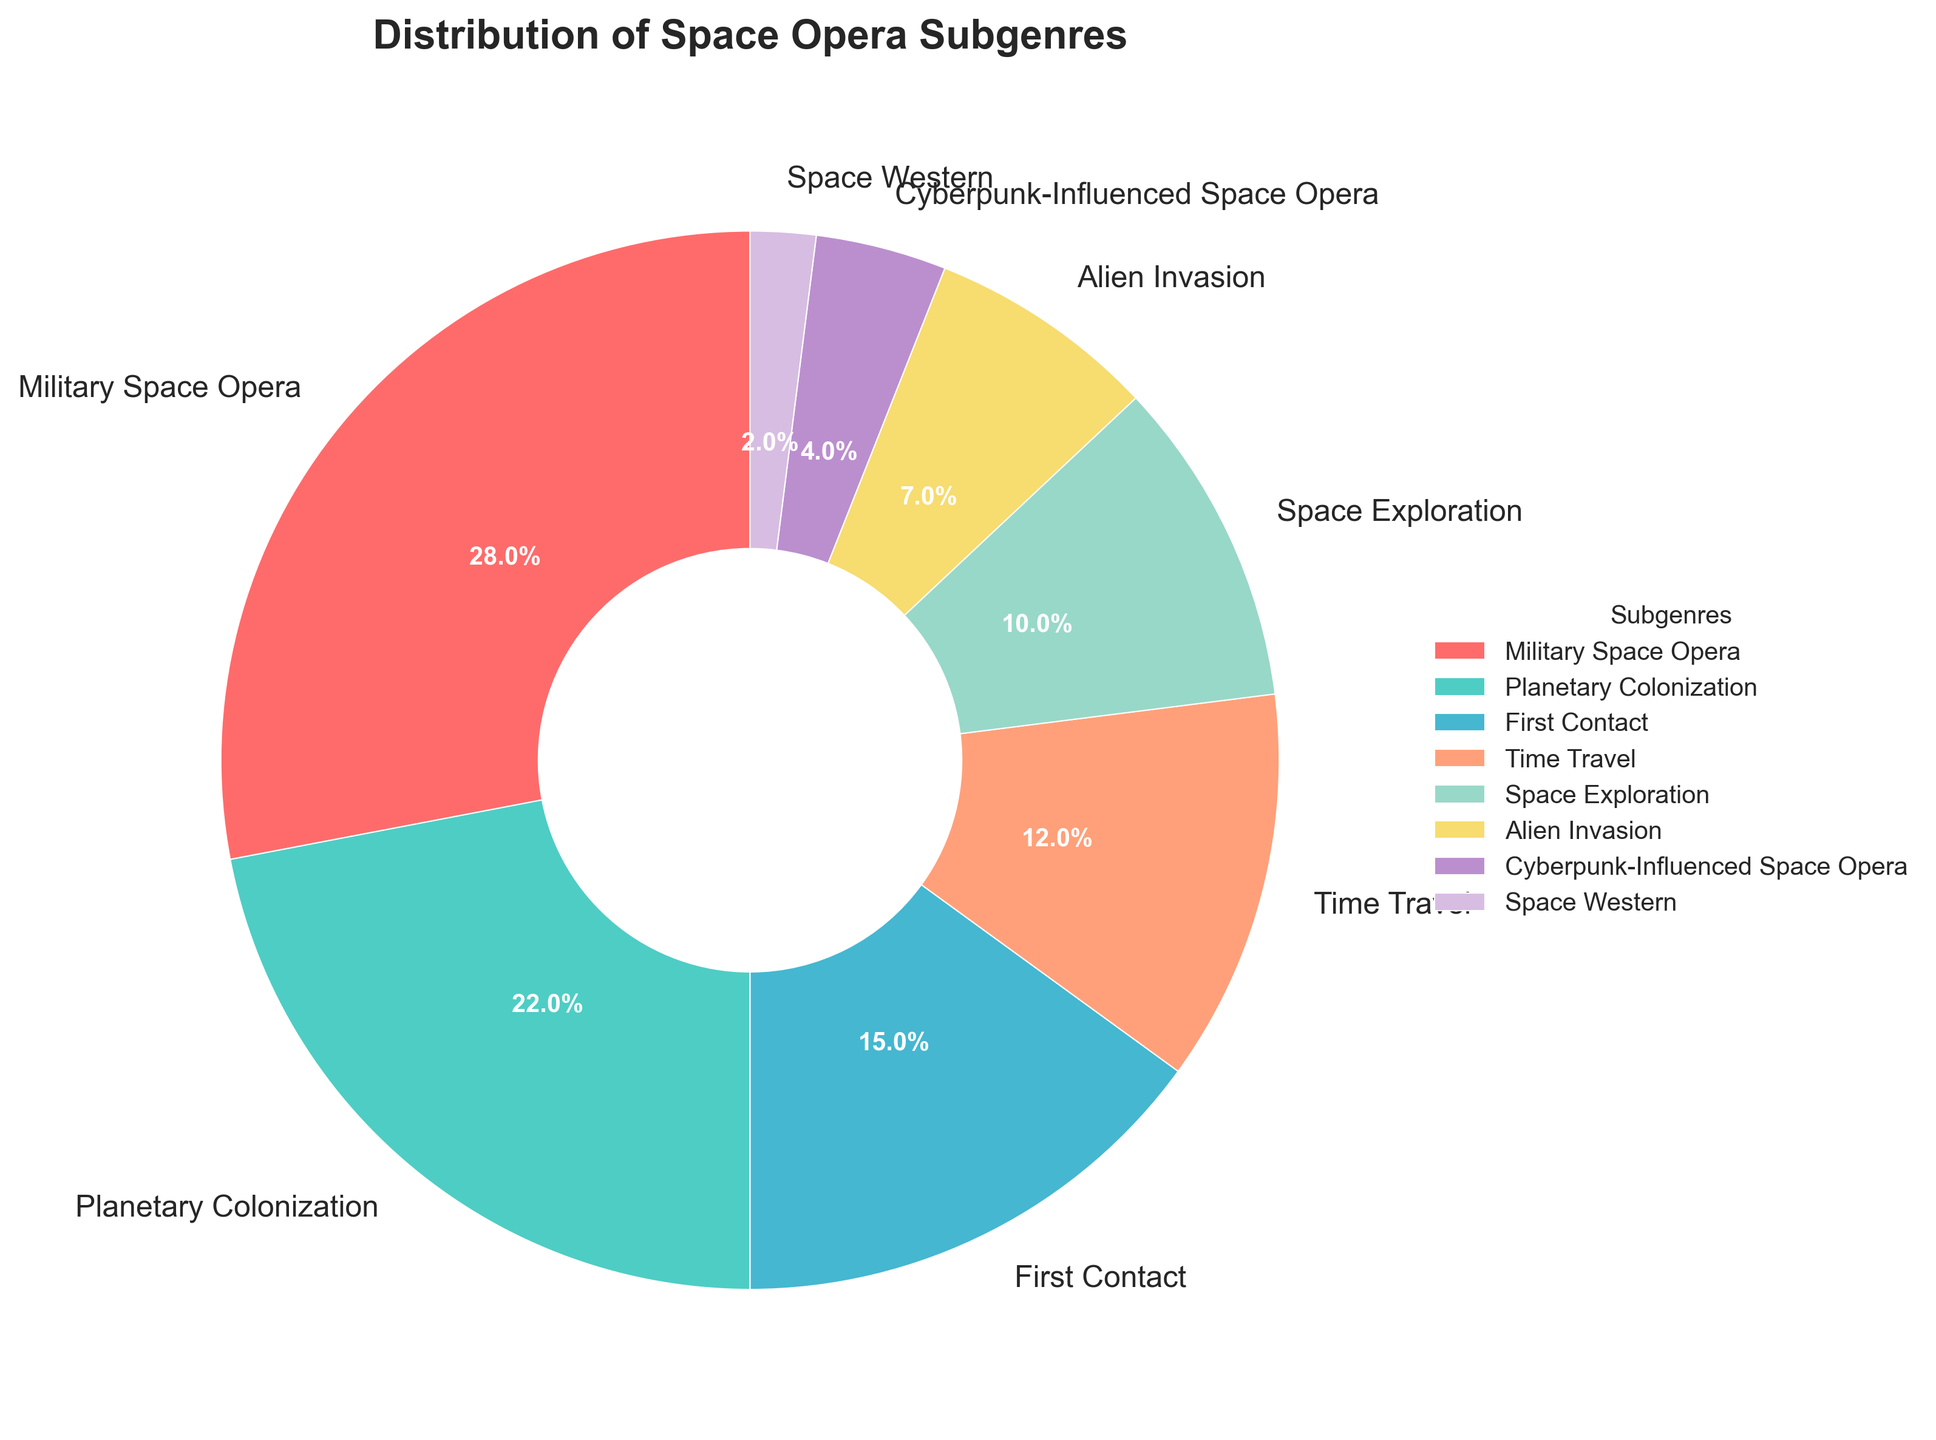What's the most popular space opera subgenre in the bookstore's sales? The chart shows that "Military Space Opera" has the highest percentage among all subgenres. By observing the labels and comparing the percentages visually, it is clear that this subgenre leads with 28%.
Answer: Military Space Opera How many subgenres have sales percentages greater than 10%? By examining the pie chart's labels, there are four subgenres with percentages higher than 10%. These are "Military Space Opera" (28%), "Planetary Colonization" (22%), "First Contact" (15%), and "Time Travel" (12%).
Answer: 4 Are there more sales in "Time Travel" or "Space Exploration"? Looking at the pie chart, "Time Travel" shows a percentage of 12%, while "Space Exploration" has a percentage of 10%. Comparing these values, it is clear that "Time Travel" subgenre has more sales.
Answer: Time Travel What's the combined percentage of the two least popular subgenres? The two least popular subgenres according to the chart are "Cyberpunk-Influenced Space Opera" (4%) and "Space Western" (2%). Adding these percentages together results in 4% + 2% = 6%.
Answer: 6% Which subgenre is represented by the yellow segment in the pie chart? By observing the color scheme in the pie chart, the yellow segment corresponds to "Space Exploration". The visual attribute of color can be directly linked to its respective subgenre.
Answer: Space Exploration By how much does "Alien Invasion" sales percentage differ from "First Contact"? From the pie chart, "Alien Invasion" shows 7% and "First Contact" shows 15%. The difference between these two percentages is 15% - 7% = 8%.
Answer: 8% What percentage of the chart is represented by subgenres starting with the letter 'S'? The subgenres starting with 'S' are "Space Exploration" (10%) and "Space Western" (2%). The cumulative percentage is 10% + 2% = 12%.
Answer: 12% Which subgenre occupies a larger segment: "Planetary Colonization" or "Time Travel"? The pie chart shows "Planetary Colonization" at 22% and "Time Travel" at 12%. Comparing these, "Planetary Colonization" occupies a larger segment.
Answer: Planetary Colonization What is the visual difference between the wedges representing “Military Space Opera” and “Space Western” subgenres? Visually, the wedge for "Military Space Opera" occupies a much larger segment (28%) compared to "Space Western" (2%) and has different colors; the former is red while the latter is purple.
Answer: Larger & different colors Based on the chart, is it true that "Cyberpunk-Influenced Space Opera" and "Space Western" together make up less than 10% of the total sales? The pie chart shows that "Cyberpunk-Influenced Space Opera" accounts for 4% and "Space Western" for 2%. Summing these gives 4% + 2% = 6%, which is less than 10%.
Answer: True 